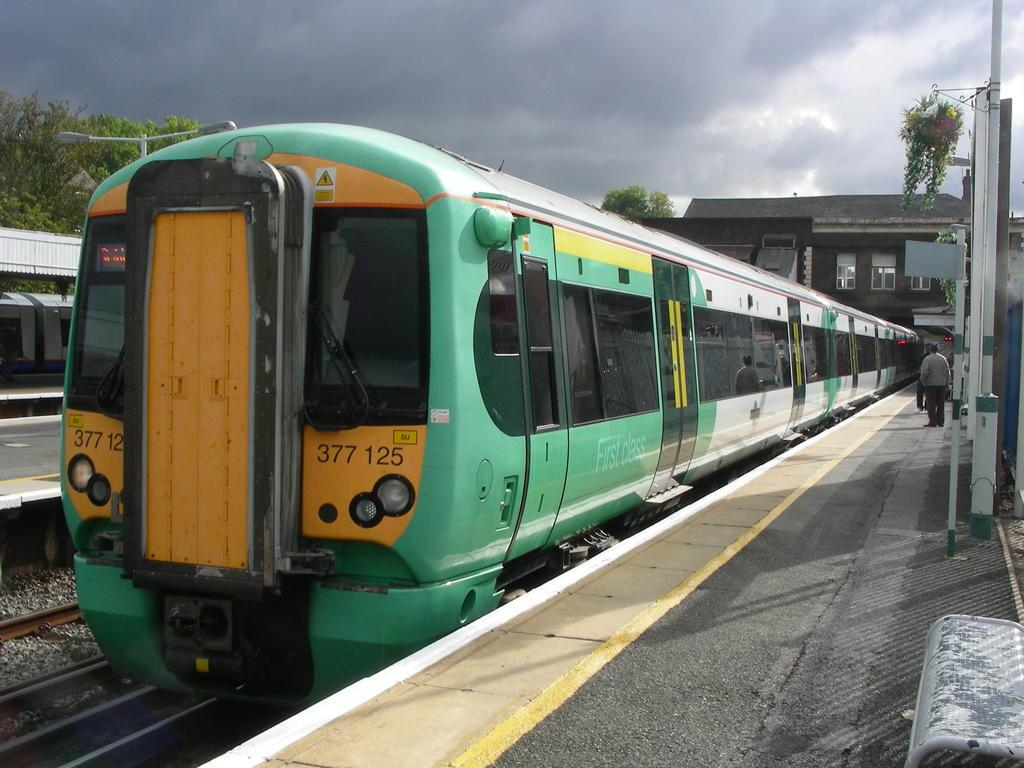<image>
Present a compact description of the photo's key features. a train that has 377 written on it 